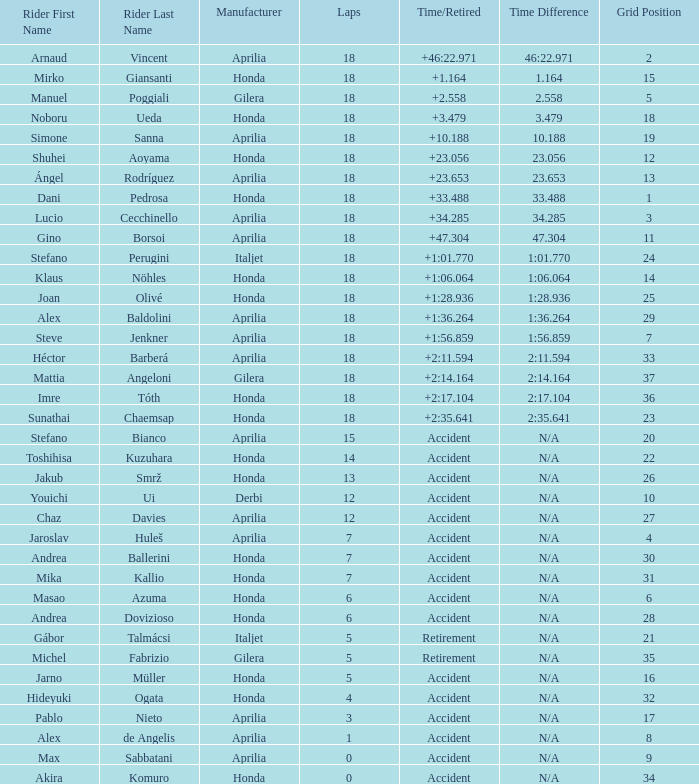Who is the rider with less than 15 laps, more than 32 grids, and an accident time/retired? Akira Komuro. 